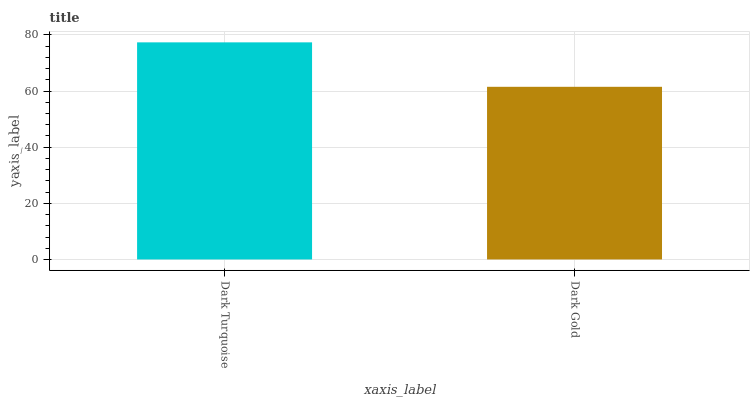Is Dark Gold the minimum?
Answer yes or no. Yes. Is Dark Turquoise the maximum?
Answer yes or no. Yes. Is Dark Gold the maximum?
Answer yes or no. No. Is Dark Turquoise greater than Dark Gold?
Answer yes or no. Yes. Is Dark Gold less than Dark Turquoise?
Answer yes or no. Yes. Is Dark Gold greater than Dark Turquoise?
Answer yes or no. No. Is Dark Turquoise less than Dark Gold?
Answer yes or no. No. Is Dark Turquoise the high median?
Answer yes or no. Yes. Is Dark Gold the low median?
Answer yes or no. Yes. Is Dark Gold the high median?
Answer yes or no. No. Is Dark Turquoise the low median?
Answer yes or no. No. 